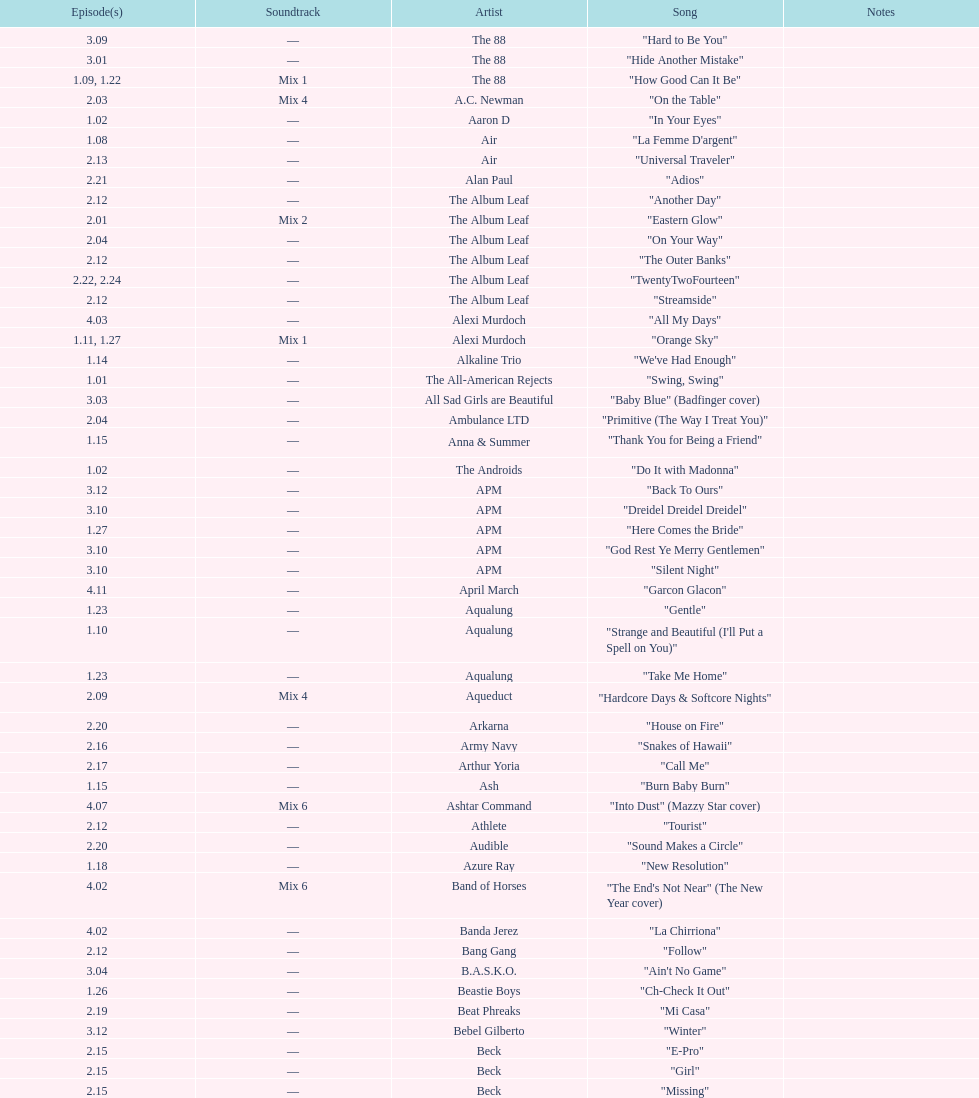What artist has more music appear in the show, daft punk or franz ferdinand? Franz Ferdinand. 